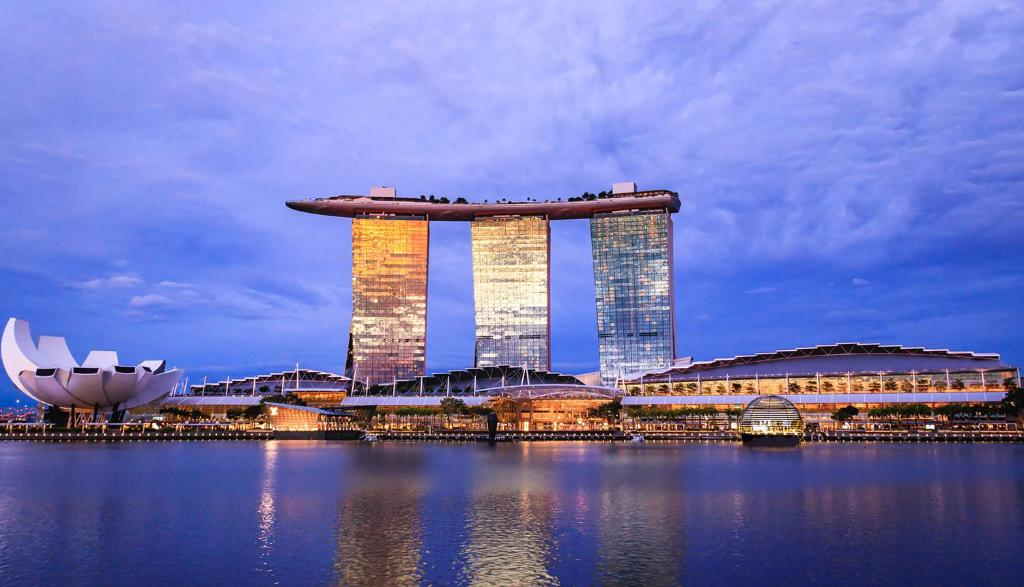Can you describe the design and purpose of the structures in this image? The image showcases Marina Bay Sands, an integrated resort designed by Moshe Safdie. The three towers are home to hotel rooms and suites, while the connecting rooftop hosts the Sands SkyPark, with a spectacular infinity pool, lush gardens, and a viewing deck. The ArtScience Museum, shaped like a lotus, symbolizes the convergence of art and science and hosts engaging exhibitions. The complex also includes a casino, theaters, and numerous dining and shopping venues. 